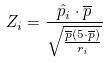Convert formula to latex. <formula><loc_0><loc_0><loc_500><loc_500>Z _ { i } = \frac { \hat { p } _ { i } \cdot \overline { p } } { \sqrt { \frac { \overline { p } ( 5 \cdot \overline { p } ) } { r _ { i } } } }</formula> 